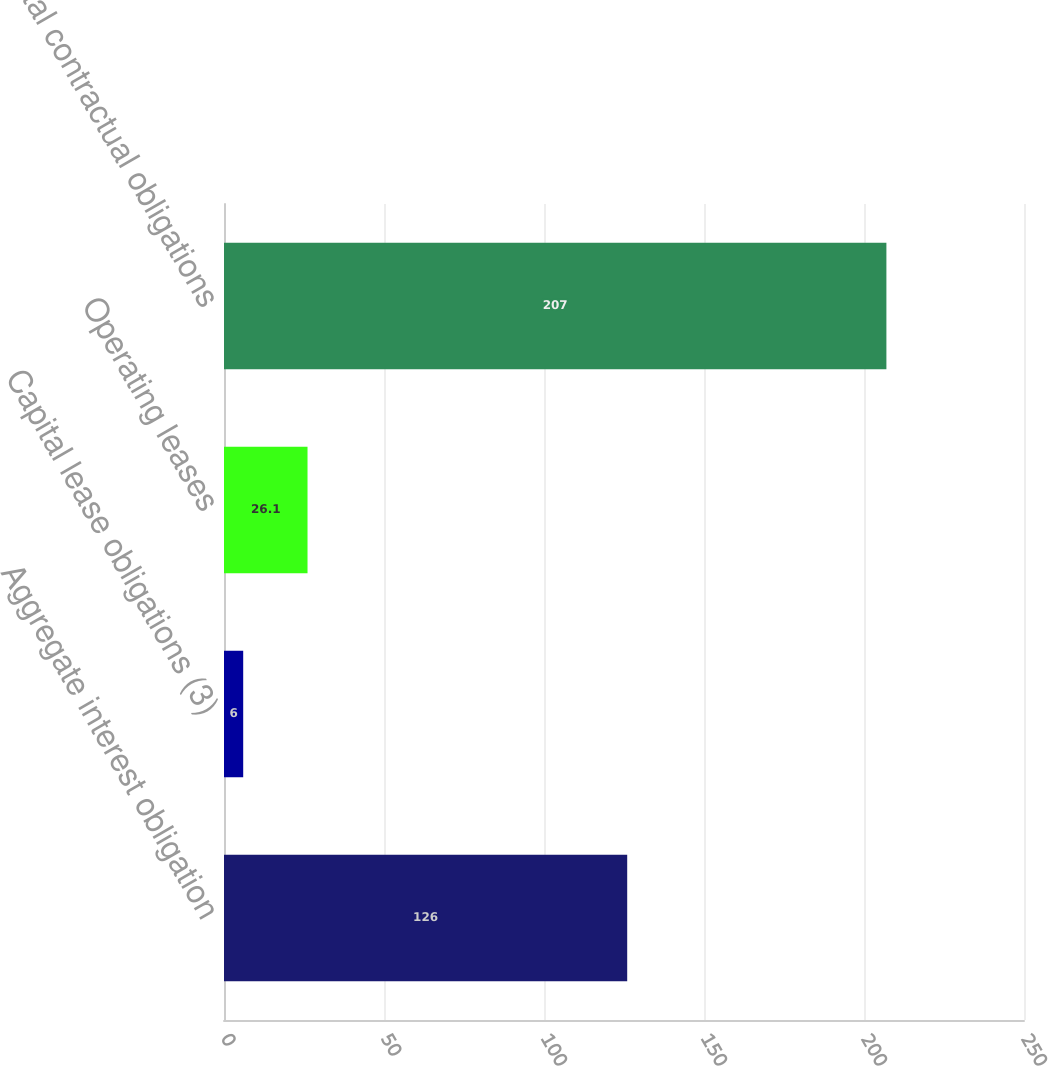Convert chart. <chart><loc_0><loc_0><loc_500><loc_500><bar_chart><fcel>Aggregate interest obligation<fcel>Capital lease obligations (3)<fcel>Operating leases<fcel>Total contractual obligations<nl><fcel>126<fcel>6<fcel>26.1<fcel>207<nl></chart> 